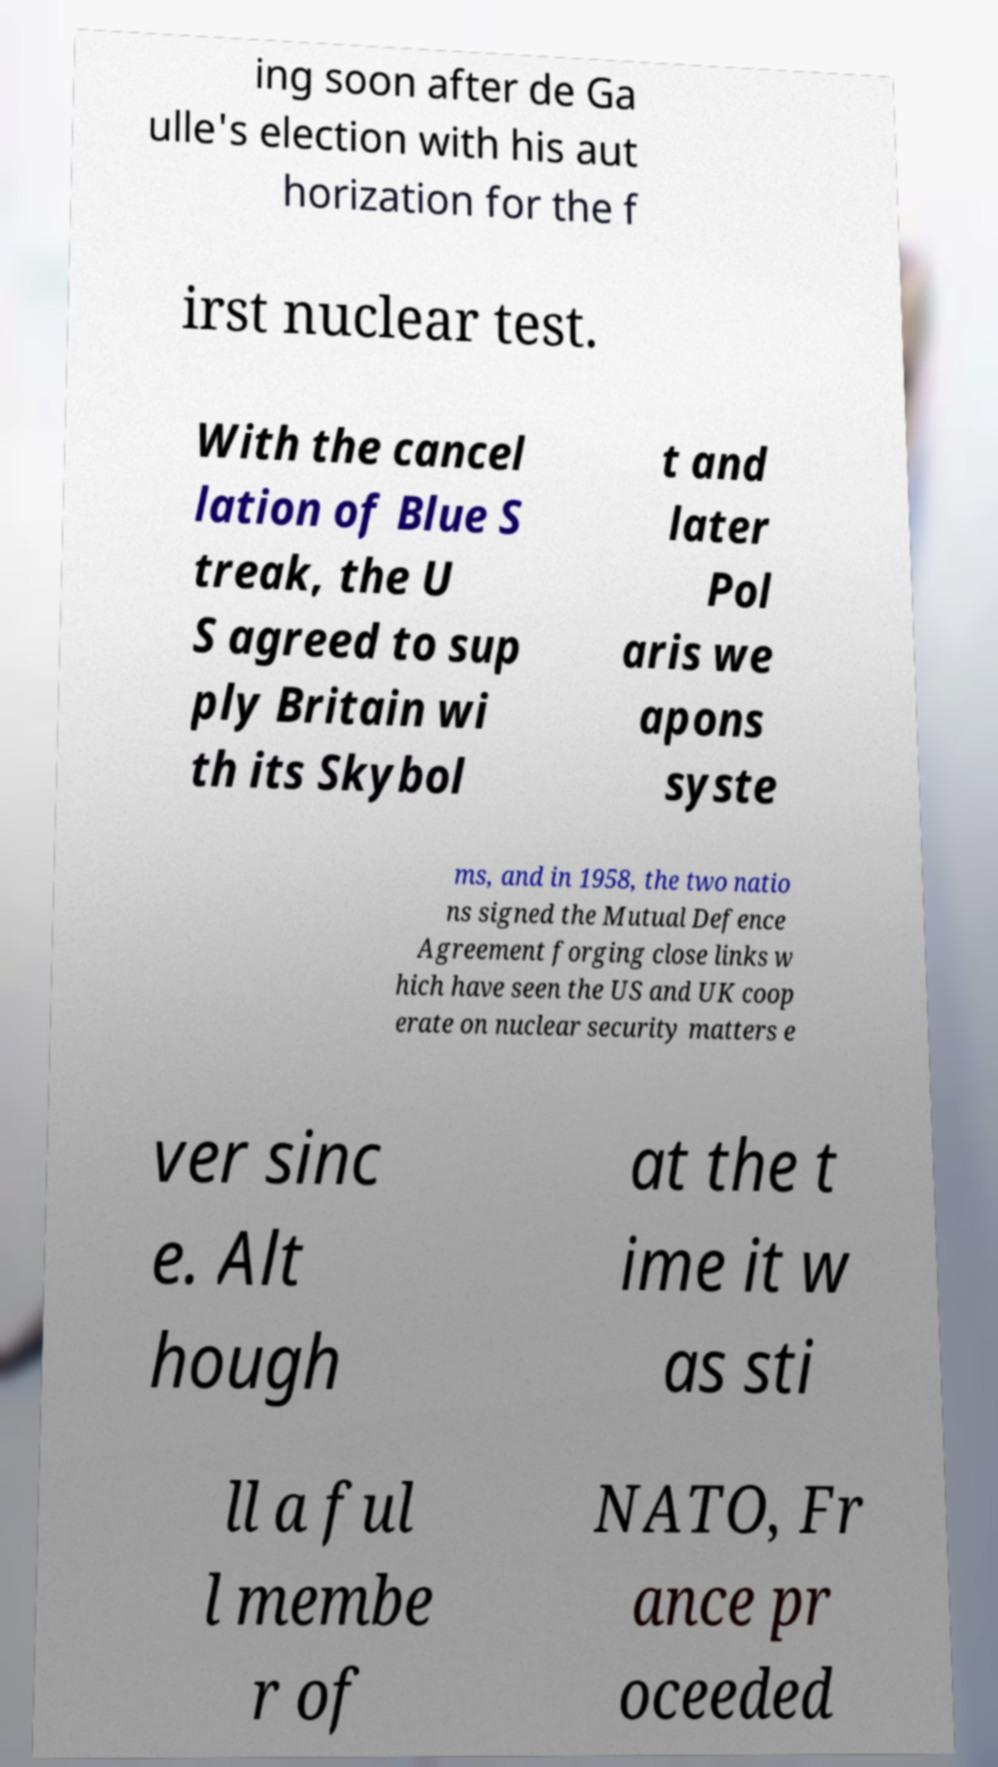Please read and relay the text visible in this image. What does it say? ing soon after de Ga ulle's election with his aut horization for the f irst nuclear test. With the cancel lation of Blue S treak, the U S agreed to sup ply Britain wi th its Skybol t and later Pol aris we apons syste ms, and in 1958, the two natio ns signed the Mutual Defence Agreement forging close links w hich have seen the US and UK coop erate on nuclear security matters e ver sinc e. Alt hough at the t ime it w as sti ll a ful l membe r of NATO, Fr ance pr oceeded 